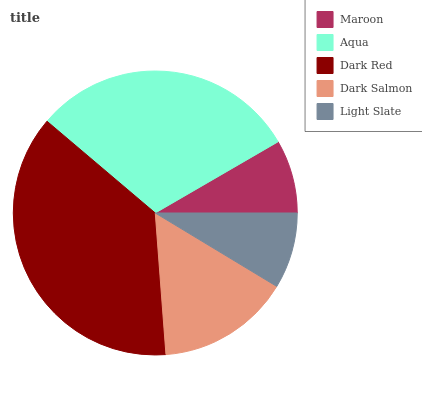Is Maroon the minimum?
Answer yes or no. Yes. Is Dark Red the maximum?
Answer yes or no. Yes. Is Aqua the minimum?
Answer yes or no. No. Is Aqua the maximum?
Answer yes or no. No. Is Aqua greater than Maroon?
Answer yes or no. Yes. Is Maroon less than Aqua?
Answer yes or no. Yes. Is Maroon greater than Aqua?
Answer yes or no. No. Is Aqua less than Maroon?
Answer yes or no. No. Is Dark Salmon the high median?
Answer yes or no. Yes. Is Dark Salmon the low median?
Answer yes or no. Yes. Is Dark Red the high median?
Answer yes or no. No. Is Maroon the low median?
Answer yes or no. No. 